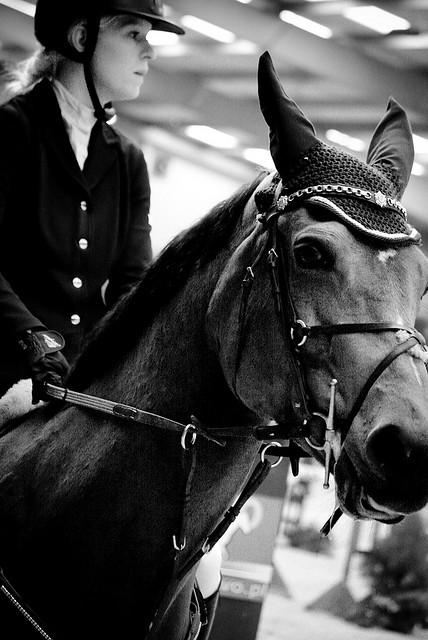What is on the horse's head?
Give a very brief answer. Hat. What is on the riders head?
Be succinct. Helmet. Would you let your child learn to ride a horse?
Quick response, please. Yes. 